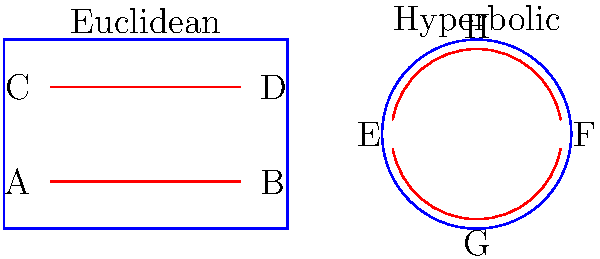In the context of multi-dimensional racing circuits, compare the behavior of parallel lines in Euclidean and hyperbolic geometries. How would this difference affect the design of a virtual racing track that incorporates both geometries? To understand the implications for multi-dimensional racing circuits, let's analyze the behavior of parallel lines in both geometries:

1. Euclidean Geometry (left side of the diagram):
   - Lines AB and CD are parallel and maintain a constant distance.
   - They never intersect, regardless of how far they are extended.
   - The sum of angles in a triangle is always 180°.

2. Hyperbolic Geometry (right side, Poincaré disk model):
   - Lines EF and GH appear curved but are "straight" in hyperbolic space.
   - These lines diverge from each other as they extend towards the boundary.
   - The sum of angles in a triangle is less than 180°.

3. Implications for multi-dimensional racing circuits:
   - In Euclidean sections, racers would experience familiar, predictable trajectories.
   - In hyperbolic sections, parallel tracks would diverge, creating unique challenges:
     a) Increased difficulty in maintaining relative positions.
     b) Optical illusions due to curved "straight" lines.
     c) Counterintuitive shortest paths between points.

4. Design considerations:
   - Transitions between Euclidean and hyperbolic sections could create exciting "warp zones."
   - Hyperbolic sections could offer multiple path choices with varying difficulties.
   - The divergence of parallel lines in hyperbolic space could be used to create natural "spread out" areas for overtaking.

5. Racing strategy implications:
   - Racers would need to adapt their techniques when moving between geometries.
   - Understanding the properties of each geometry would be crucial for optimizing race lines.
   - New skills would be required to navigate the unique spatial relationships in hyperbolic sections.

This combination of geometries would create a racing experience that goes beyond traditional motorsports, offering a truly multi-dimensional challenge that leverages the unique properties of different spatial structures.
Answer: Parallel lines remain equidistant in Euclidean space but diverge in hyperbolic space, allowing for diverse track designs with varying difficulties and strategic options in multi-dimensional racing circuits. 